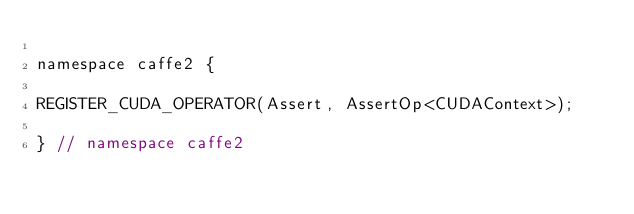Convert code to text. <code><loc_0><loc_0><loc_500><loc_500><_Cuda_>
namespace caffe2 {

REGISTER_CUDA_OPERATOR(Assert, AssertOp<CUDAContext>);

} // namespace caffe2
</code> 